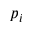<formula> <loc_0><loc_0><loc_500><loc_500>p _ { i }</formula> 